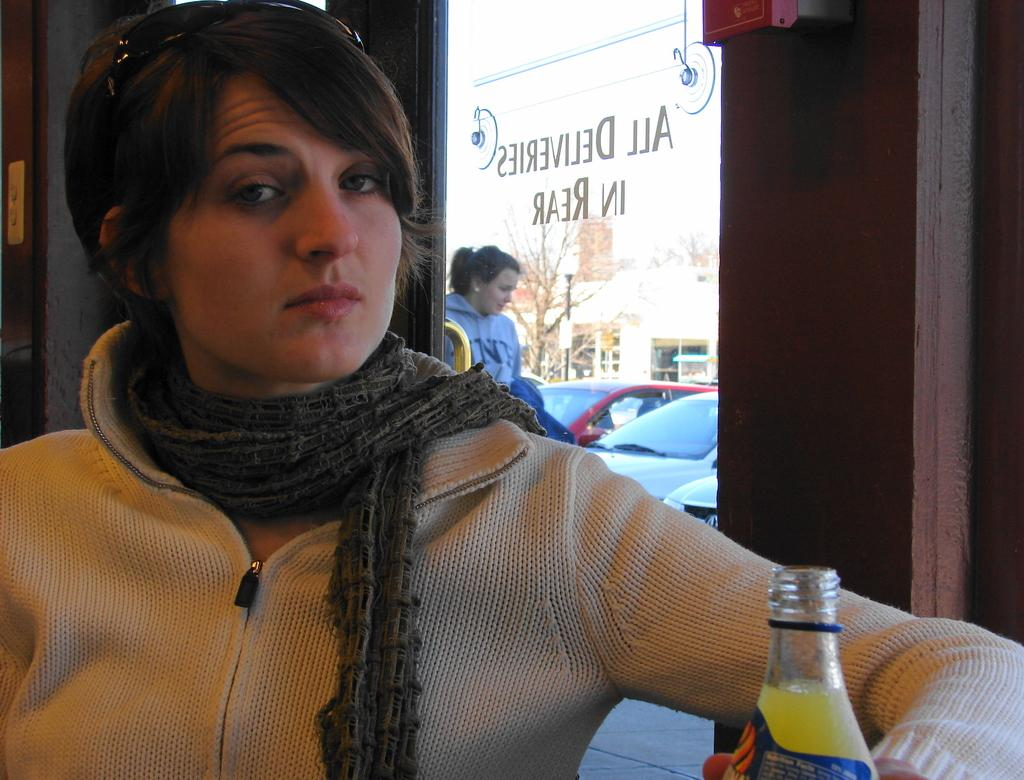Who is the main subject in the image? There is a lady in the center of the image. What is the lady holding in her hand? The lady is holding a bottle in her hand. What can be seen in the background of the image? There is a door, cars, trees, and the sky visible in the background of the image. What type of authority does the lady have in the image? There is no indication of the lady having any authority in the image. Can you tell me what color the lady's sock is in the image? There is no sock visible in the image, so it cannot be determined what color it might be. 